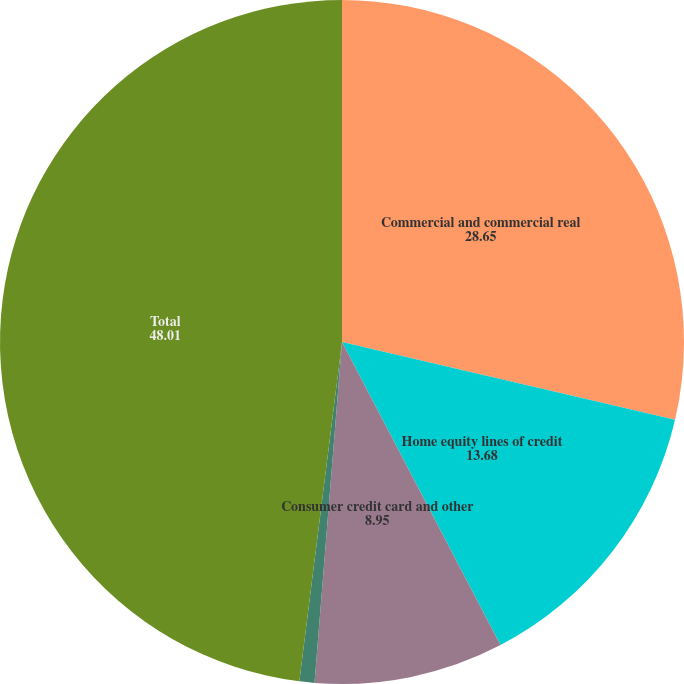<chart> <loc_0><loc_0><loc_500><loc_500><pie_chart><fcel>Commercial and commercial real<fcel>Home equity lines of credit<fcel>Consumer credit card and other<fcel>Other<fcel>Total<nl><fcel>28.65%<fcel>13.68%<fcel>8.95%<fcel>0.71%<fcel>48.01%<nl></chart> 